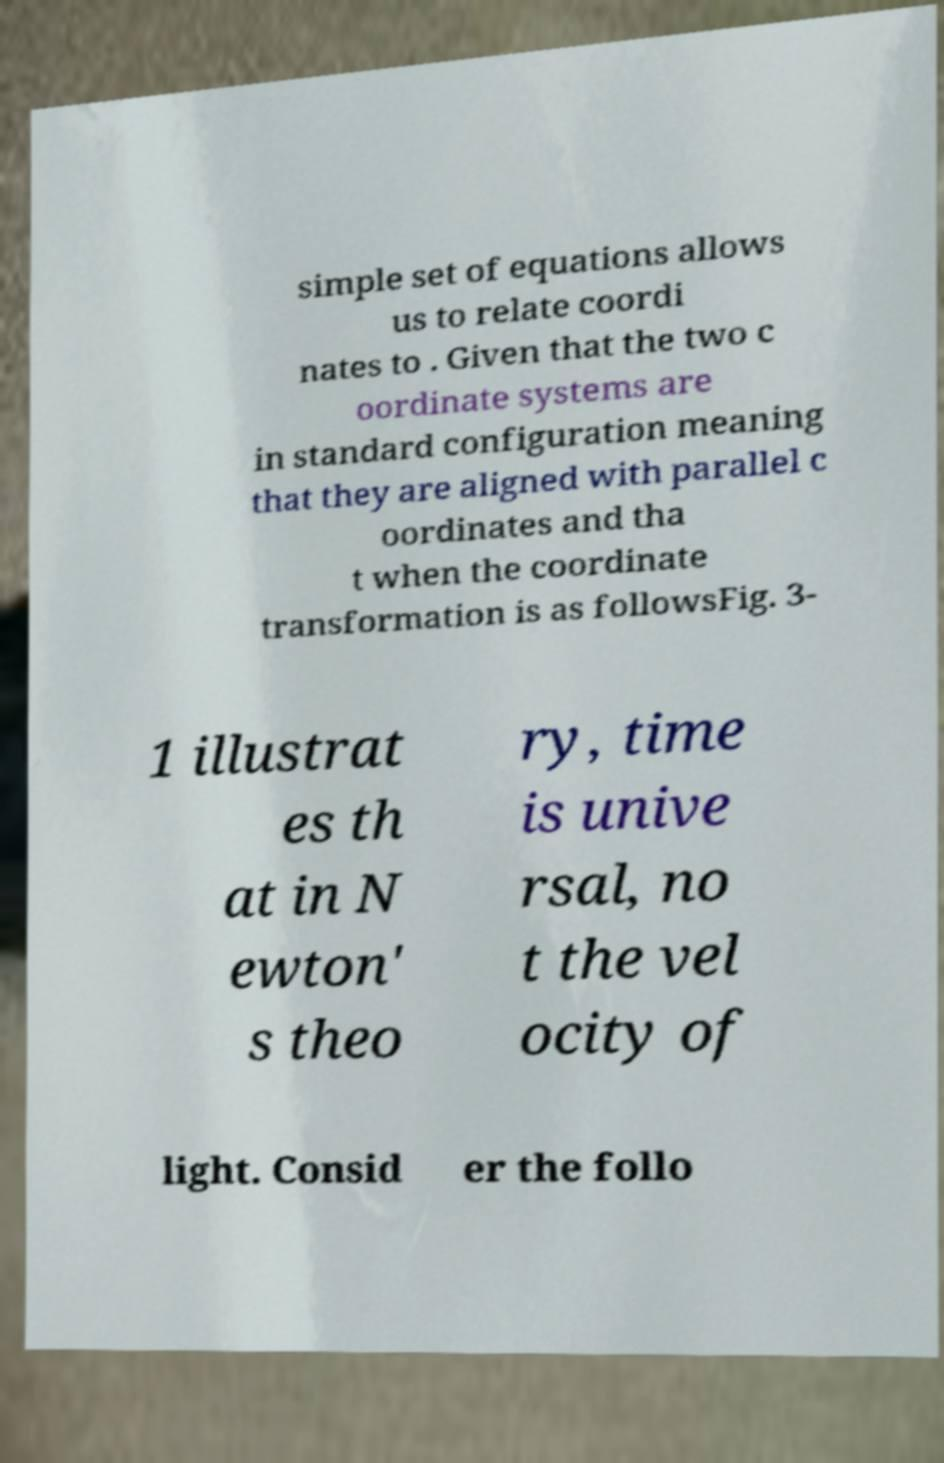There's text embedded in this image that I need extracted. Can you transcribe it verbatim? simple set of equations allows us to relate coordi nates to . Given that the two c oordinate systems are in standard configuration meaning that they are aligned with parallel c oordinates and tha t when the coordinate transformation is as followsFig. 3- 1 illustrat es th at in N ewton' s theo ry, time is unive rsal, no t the vel ocity of light. Consid er the follo 